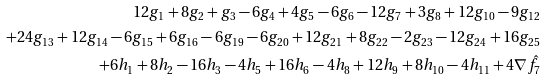Convert formula to latex. <formula><loc_0><loc_0><loc_500><loc_500>1 2 g _ { 1 } + 8 g _ { 2 } + g _ { 3 } - 6 g _ { 4 } + 4 g _ { 5 } - 6 g _ { 6 } - 1 2 g _ { 7 } + 3 g _ { 8 } + 1 2 g _ { 1 0 } - 9 g _ { 1 2 } \\ + 2 4 g _ { 1 3 } + 1 2 g _ { 1 4 } - 6 g _ { 1 5 } + 6 g _ { 1 6 } - 6 g _ { 1 9 } - 6 g _ { 2 0 } + 1 2 g _ { 2 1 } + 8 g _ { 2 2 } - 2 g _ { 2 3 } - 1 2 g _ { 2 4 } + 1 6 g _ { 2 5 } \\ + 6 h _ { 1 } + 8 h _ { 2 } - 1 6 h _ { 3 } - 4 h _ { 5 } + 1 6 h _ { 6 } - 4 h _ { 8 } + 1 2 h _ { 9 } + 8 h _ { 1 0 } - 4 h _ { 1 1 } + 4 \nabla \hat { f } _ { 7 }</formula> 